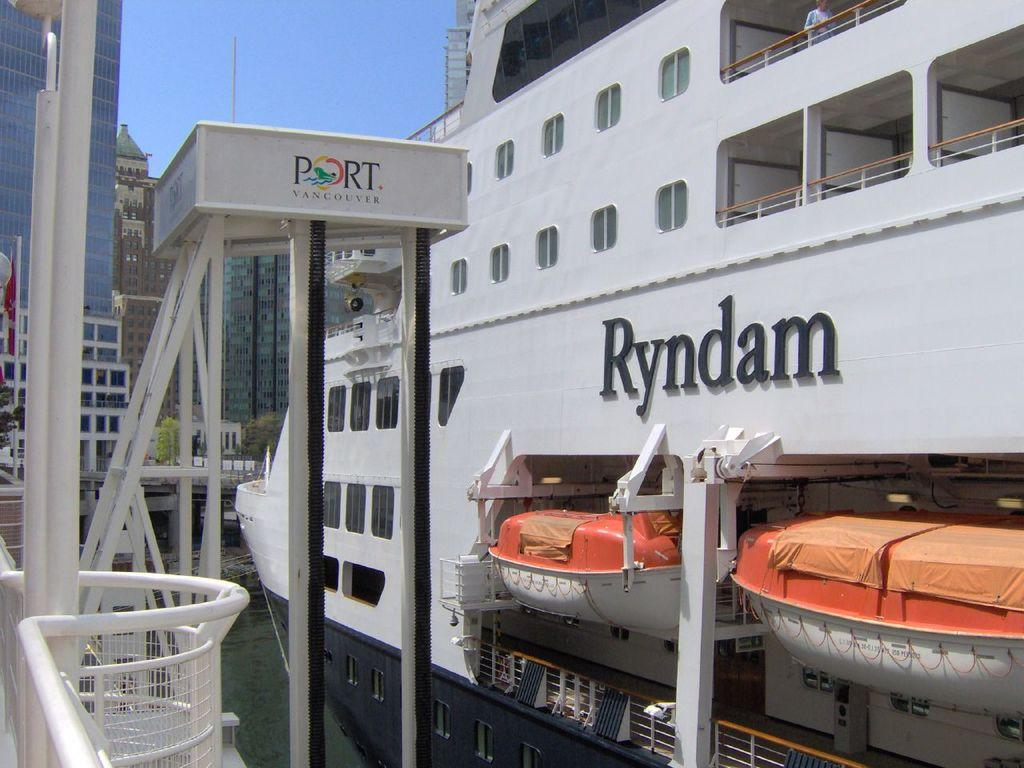<image>
Present a compact description of the photo's key features. A large boat is docked at the Port of Vancouver. 